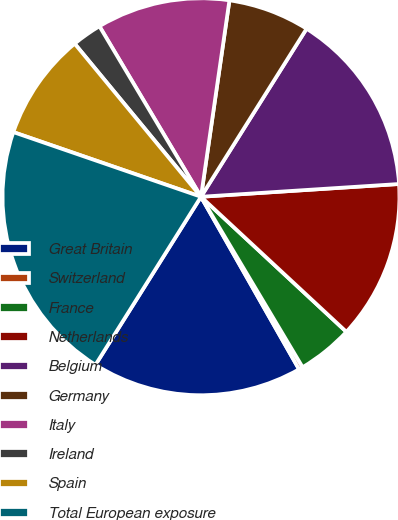<chart> <loc_0><loc_0><loc_500><loc_500><pie_chart><fcel>Great Britain<fcel>Switzerland<fcel>France<fcel>Netherlands<fcel>Belgium<fcel>Germany<fcel>Italy<fcel>Ireland<fcel>Spain<fcel>Total European exposure<nl><fcel>17.15%<fcel>0.33%<fcel>4.53%<fcel>12.94%<fcel>15.05%<fcel>6.64%<fcel>10.84%<fcel>2.43%<fcel>8.74%<fcel>21.36%<nl></chart> 